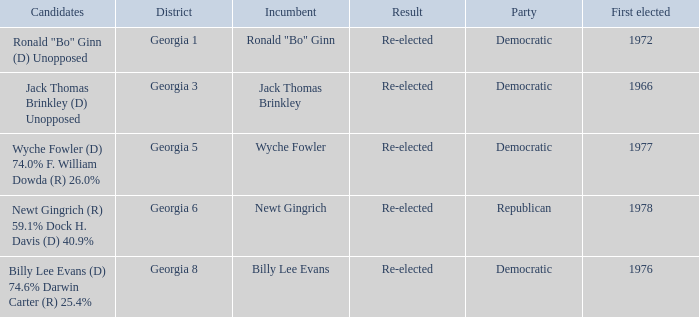How many nominees were first chosen in 1972? 1.0. 